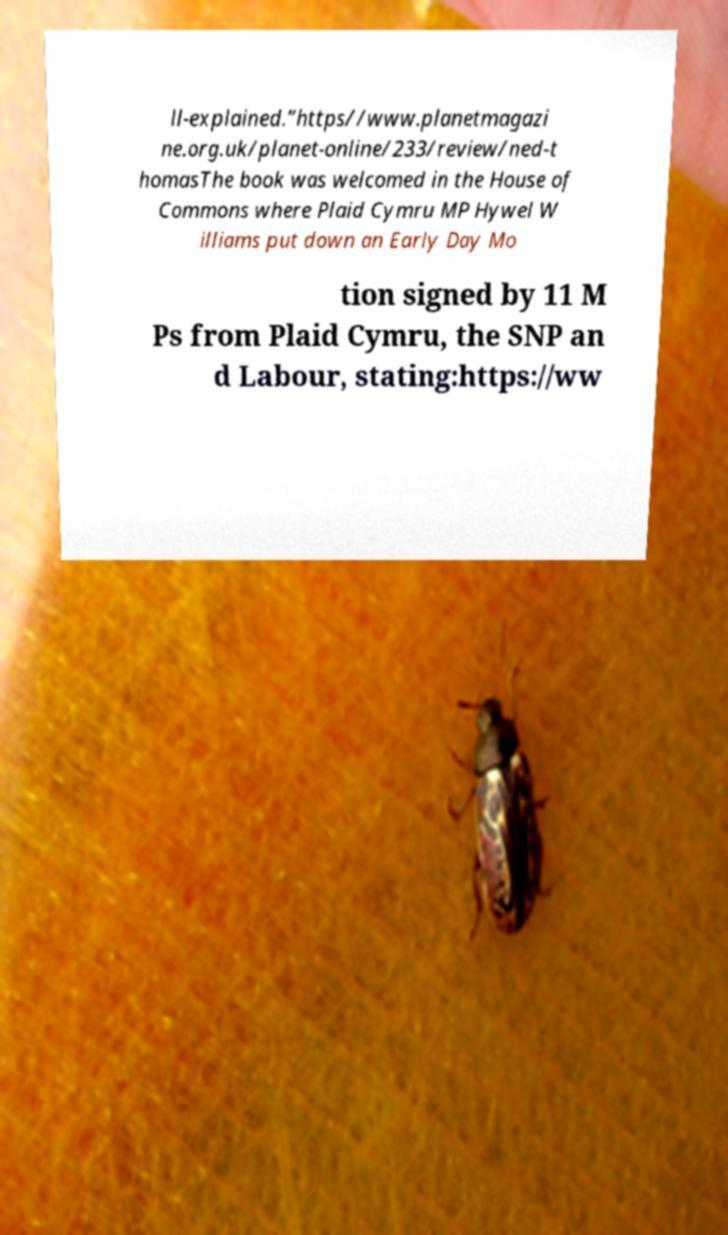Please read and relay the text visible in this image. What does it say? ll-explained.”https//www.planetmagazi ne.org.uk/planet-online/233/review/ned-t homasThe book was welcomed in the House of Commons where Plaid Cymru MP Hywel W illiams put down an Early Day Mo tion signed by 11 M Ps from Plaid Cymru, the SNP an d Labour, stating:https://ww 